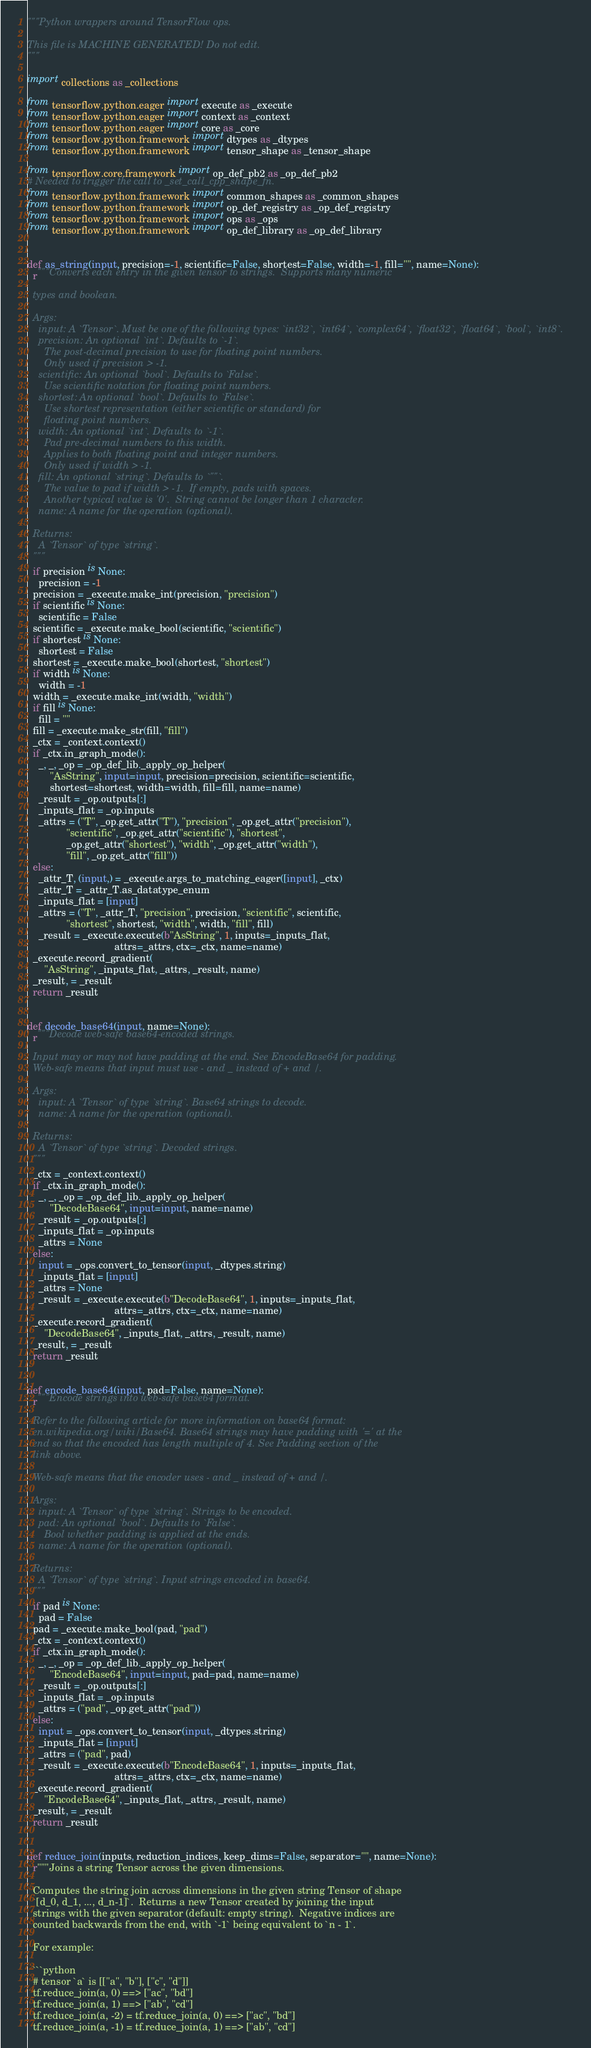<code> <loc_0><loc_0><loc_500><loc_500><_Python_>"""Python wrappers around TensorFlow ops.

This file is MACHINE GENERATED! Do not edit.
"""

import collections as _collections

from tensorflow.python.eager import execute as _execute
from tensorflow.python.eager import context as _context
from tensorflow.python.eager import core as _core
from tensorflow.python.framework import dtypes as _dtypes
from tensorflow.python.framework import tensor_shape as _tensor_shape

from tensorflow.core.framework import op_def_pb2 as _op_def_pb2
# Needed to trigger the call to _set_call_cpp_shape_fn.
from tensorflow.python.framework import common_shapes as _common_shapes
from tensorflow.python.framework import op_def_registry as _op_def_registry
from tensorflow.python.framework import ops as _ops
from tensorflow.python.framework import op_def_library as _op_def_library


def as_string(input, precision=-1, scientific=False, shortest=False, width=-1, fill="", name=None):
  r"""Converts each entry in the given tensor to strings.  Supports many numeric

  types and boolean.

  Args:
    input: A `Tensor`. Must be one of the following types: `int32`, `int64`, `complex64`, `float32`, `float64`, `bool`, `int8`.
    precision: An optional `int`. Defaults to `-1`.
      The post-decimal precision to use for floating point numbers.
      Only used if precision > -1.
    scientific: An optional `bool`. Defaults to `False`.
      Use scientific notation for floating point numbers.
    shortest: An optional `bool`. Defaults to `False`.
      Use shortest representation (either scientific or standard) for
      floating point numbers.
    width: An optional `int`. Defaults to `-1`.
      Pad pre-decimal numbers to this width.
      Applies to both floating point and integer numbers.
      Only used if width > -1.
    fill: An optional `string`. Defaults to `""`.
      The value to pad if width > -1.  If empty, pads with spaces.
      Another typical value is '0'.  String cannot be longer than 1 character.
    name: A name for the operation (optional).

  Returns:
    A `Tensor` of type `string`.
  """
  if precision is None:
    precision = -1
  precision = _execute.make_int(precision, "precision")
  if scientific is None:
    scientific = False
  scientific = _execute.make_bool(scientific, "scientific")
  if shortest is None:
    shortest = False
  shortest = _execute.make_bool(shortest, "shortest")
  if width is None:
    width = -1
  width = _execute.make_int(width, "width")
  if fill is None:
    fill = ""
  fill = _execute.make_str(fill, "fill")
  _ctx = _context.context()
  if _ctx.in_graph_mode():
    _, _, _op = _op_def_lib._apply_op_helper(
        "AsString", input=input, precision=precision, scientific=scientific,
        shortest=shortest, width=width, fill=fill, name=name)
    _result = _op.outputs[:]
    _inputs_flat = _op.inputs
    _attrs = ("T", _op.get_attr("T"), "precision", _op.get_attr("precision"),
              "scientific", _op.get_attr("scientific"), "shortest",
              _op.get_attr("shortest"), "width", _op.get_attr("width"),
              "fill", _op.get_attr("fill"))
  else:
    _attr_T, (input,) = _execute.args_to_matching_eager([input], _ctx)
    _attr_T = _attr_T.as_datatype_enum
    _inputs_flat = [input]
    _attrs = ("T", _attr_T, "precision", precision, "scientific", scientific,
              "shortest", shortest, "width", width, "fill", fill)
    _result = _execute.execute(b"AsString", 1, inputs=_inputs_flat,
                               attrs=_attrs, ctx=_ctx, name=name)
  _execute.record_gradient(
      "AsString", _inputs_flat, _attrs, _result, name)
  _result, = _result
  return _result


def decode_base64(input, name=None):
  r"""Decode web-safe base64-encoded strings.

  Input may or may not have padding at the end. See EncodeBase64 for padding.
  Web-safe means that input must use - and _ instead of + and /.

  Args:
    input: A `Tensor` of type `string`. Base64 strings to decode.
    name: A name for the operation (optional).

  Returns:
    A `Tensor` of type `string`. Decoded strings.
  """
  _ctx = _context.context()
  if _ctx.in_graph_mode():
    _, _, _op = _op_def_lib._apply_op_helper(
        "DecodeBase64", input=input, name=name)
    _result = _op.outputs[:]
    _inputs_flat = _op.inputs
    _attrs = None
  else:
    input = _ops.convert_to_tensor(input, _dtypes.string)
    _inputs_flat = [input]
    _attrs = None
    _result = _execute.execute(b"DecodeBase64", 1, inputs=_inputs_flat,
                               attrs=_attrs, ctx=_ctx, name=name)
  _execute.record_gradient(
      "DecodeBase64", _inputs_flat, _attrs, _result, name)
  _result, = _result
  return _result


def encode_base64(input, pad=False, name=None):
  r"""Encode strings into web-safe base64 format.

  Refer to the following article for more information on base64 format:
  en.wikipedia.org/wiki/Base64. Base64 strings may have padding with '=' at the
  end so that the encoded has length multiple of 4. See Padding section of the
  link above.

  Web-safe means that the encoder uses - and _ instead of + and /.

  Args:
    input: A `Tensor` of type `string`. Strings to be encoded.
    pad: An optional `bool`. Defaults to `False`.
      Bool whether padding is applied at the ends.
    name: A name for the operation (optional).

  Returns:
    A `Tensor` of type `string`. Input strings encoded in base64.
  """
  if pad is None:
    pad = False
  pad = _execute.make_bool(pad, "pad")
  _ctx = _context.context()
  if _ctx.in_graph_mode():
    _, _, _op = _op_def_lib._apply_op_helper(
        "EncodeBase64", input=input, pad=pad, name=name)
    _result = _op.outputs[:]
    _inputs_flat = _op.inputs
    _attrs = ("pad", _op.get_attr("pad"))
  else:
    input = _ops.convert_to_tensor(input, _dtypes.string)
    _inputs_flat = [input]
    _attrs = ("pad", pad)
    _result = _execute.execute(b"EncodeBase64", 1, inputs=_inputs_flat,
                               attrs=_attrs, ctx=_ctx, name=name)
  _execute.record_gradient(
      "EncodeBase64", _inputs_flat, _attrs, _result, name)
  _result, = _result
  return _result


def reduce_join(inputs, reduction_indices, keep_dims=False, separator="", name=None):
  r"""Joins a string Tensor across the given dimensions.

  Computes the string join across dimensions in the given string Tensor of shape
  `[d_0, d_1, ..., d_n-1]`.  Returns a new Tensor created by joining the input
  strings with the given separator (default: empty string).  Negative indices are
  counted backwards from the end, with `-1` being equivalent to `n - 1`.

  For example:

  ```python
  # tensor `a` is [["a", "b"], ["c", "d"]]
  tf.reduce_join(a, 0) ==> ["ac", "bd"]
  tf.reduce_join(a, 1) ==> ["ab", "cd"]
  tf.reduce_join(a, -2) = tf.reduce_join(a, 0) ==> ["ac", "bd"]
  tf.reduce_join(a, -1) = tf.reduce_join(a, 1) ==> ["ab", "cd"]</code> 